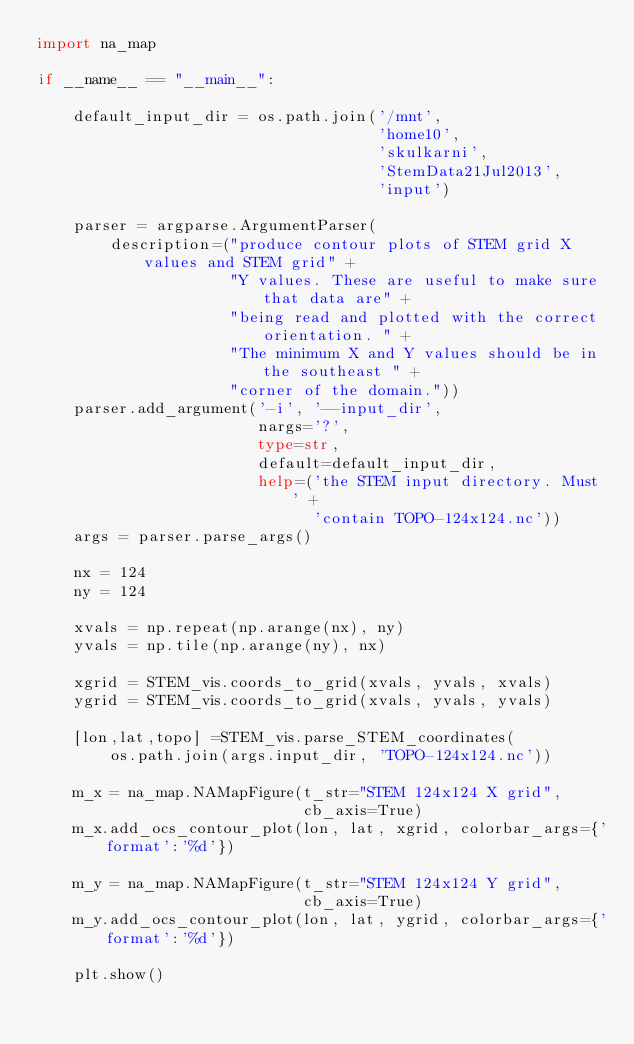<code> <loc_0><loc_0><loc_500><loc_500><_Python_>import na_map

if __name__ == "__main__":

    default_input_dir = os.path.join('/mnt',
                                     'home10',
                                     'skulkarni',
                                     'StemData21Jul2013',
                                     'input')

    parser = argparse.ArgumentParser(
        description=("produce contour plots of STEM grid X values and STEM grid" +
                     "Y values. These are useful to make sure that data are" +
                     "being read and plotted with the correct orientation. " +
                     "The minimum X and Y values should be in the southeast " +
                     "corner of the domain."))
    parser.add_argument('-i', '--input_dir',
                        nargs='?',
                        type=str,
                        default=default_input_dir,
                        help=('the STEM input directory. Must ' +
                              'contain TOPO-124x124.nc'))
    args = parser.parse_args()

    nx = 124
    ny = 124

    xvals = np.repeat(np.arange(nx), ny)
    yvals = np.tile(np.arange(ny), nx)

    xgrid = STEM_vis.coords_to_grid(xvals, yvals, xvals)
    ygrid = STEM_vis.coords_to_grid(xvals, yvals, yvals)

    [lon,lat,topo] =STEM_vis.parse_STEM_coordinates(
        os.path.join(args.input_dir, 'TOPO-124x124.nc'))

    m_x = na_map.NAMapFigure(t_str="STEM 124x124 X grid",
                             cb_axis=True)
    m_x.add_ocs_contour_plot(lon, lat, xgrid, colorbar_args={'format':'%d'})

    m_y = na_map.NAMapFigure(t_str="STEM 124x124 Y grid",
                             cb_axis=True)
    m_y.add_ocs_contour_plot(lon, lat, ygrid, colorbar_args={'format':'%d'})

    plt.show()
</code> 